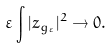<formula> <loc_0><loc_0><loc_500><loc_500>\varepsilon \int | z _ { g _ { \varepsilon } } | ^ { 2 } \rightarrow 0 .</formula> 